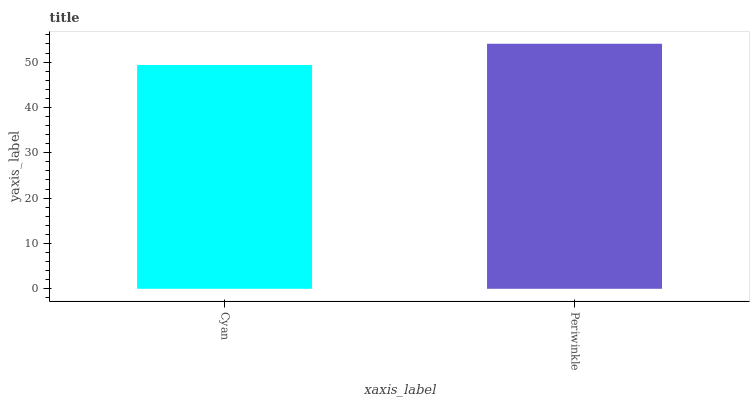Is Cyan the minimum?
Answer yes or no. Yes. Is Periwinkle the maximum?
Answer yes or no. Yes. Is Periwinkle the minimum?
Answer yes or no. No. Is Periwinkle greater than Cyan?
Answer yes or no. Yes. Is Cyan less than Periwinkle?
Answer yes or no. Yes. Is Cyan greater than Periwinkle?
Answer yes or no. No. Is Periwinkle less than Cyan?
Answer yes or no. No. Is Periwinkle the high median?
Answer yes or no. Yes. Is Cyan the low median?
Answer yes or no. Yes. Is Cyan the high median?
Answer yes or no. No. Is Periwinkle the low median?
Answer yes or no. No. 